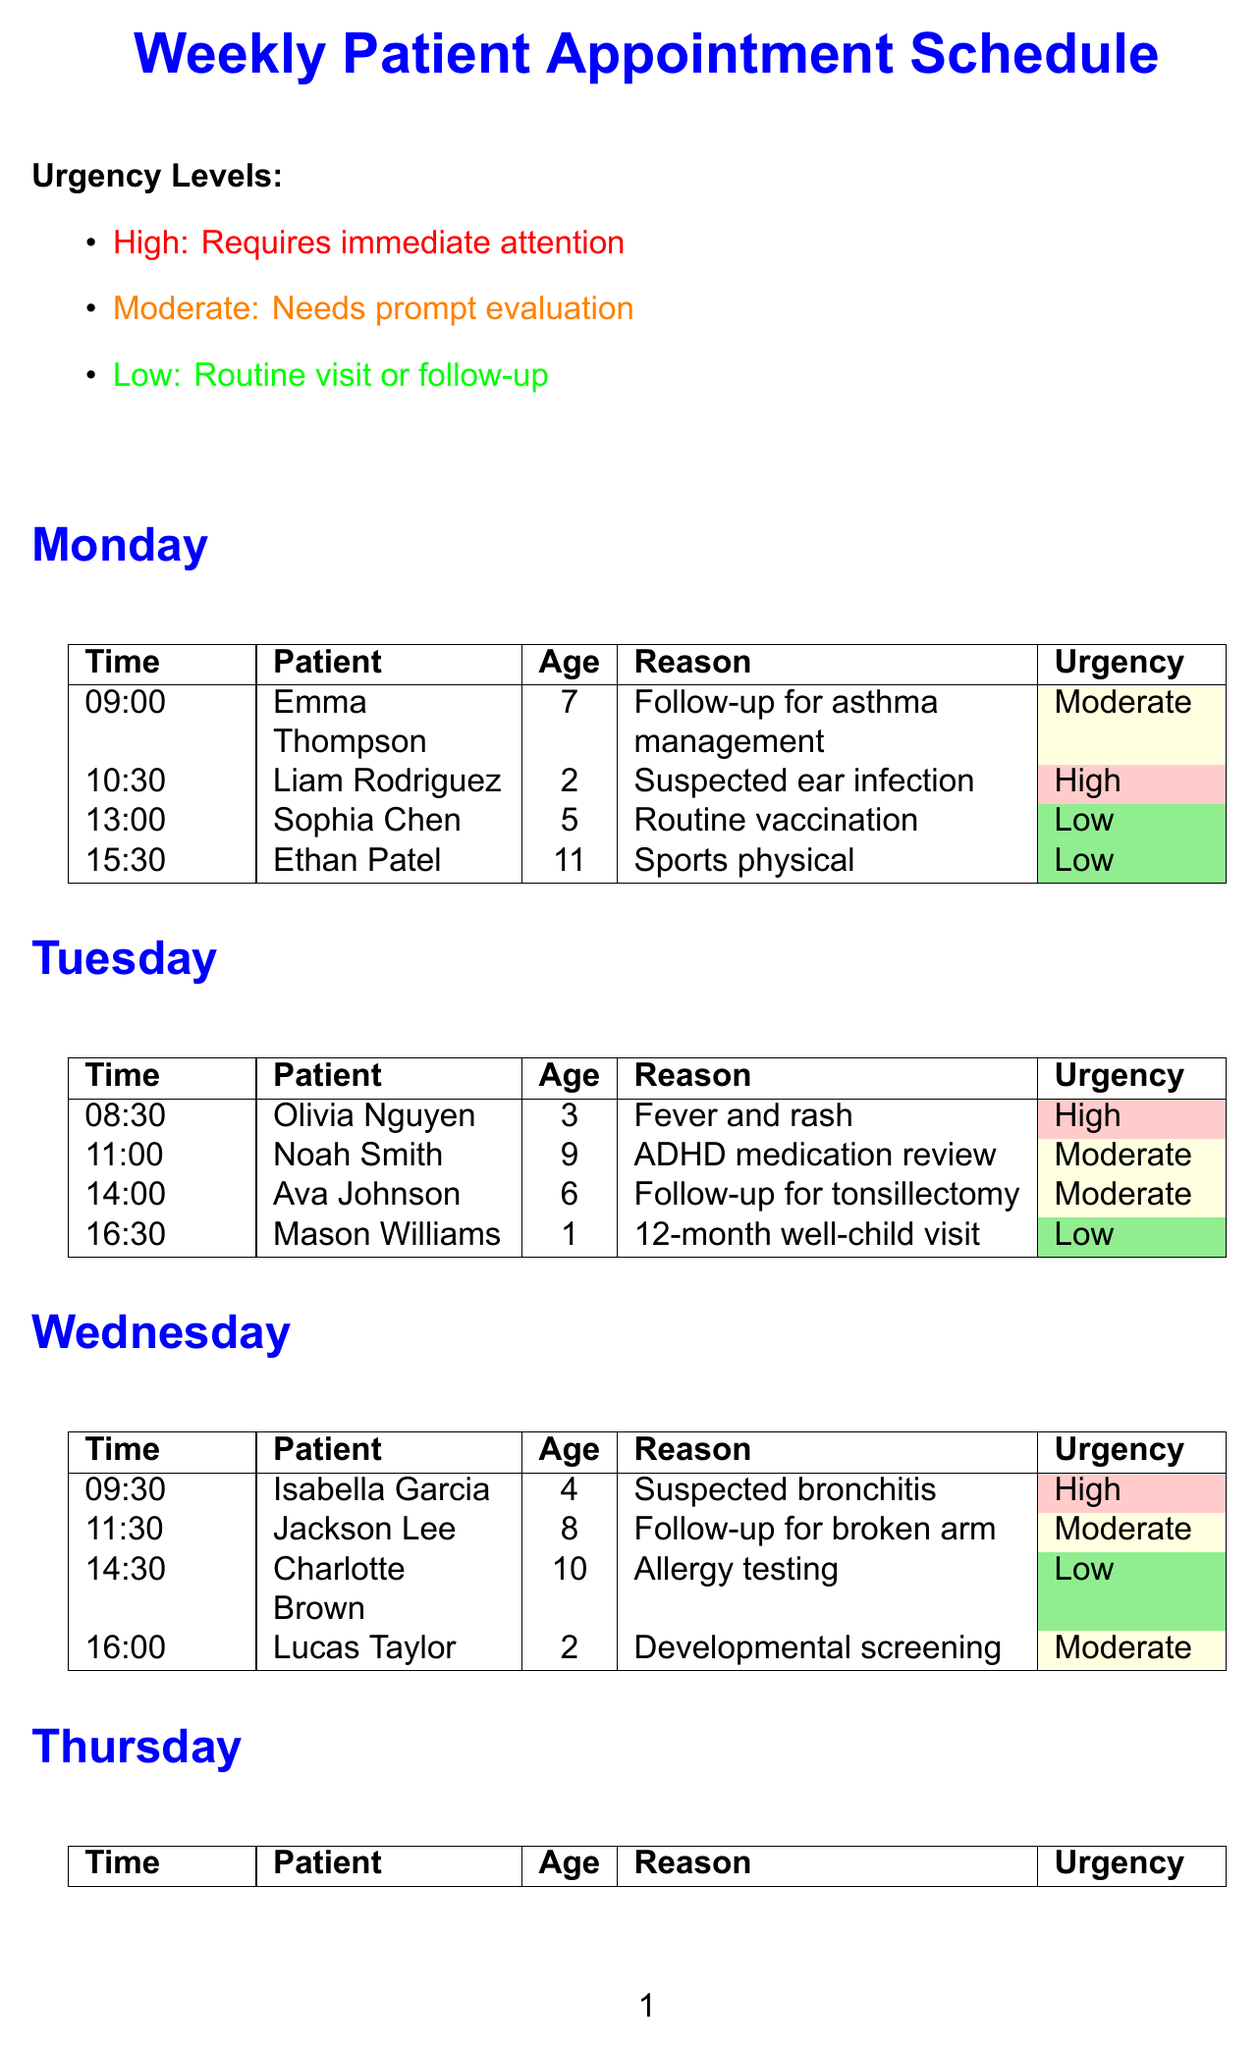What is the reason for Liam Rodriguez's appointment? The reason is specified in the document as "Suspected ear infection."
Answer: Suspected ear infection How many appointments are there on Thursday? The document lists four appointments for Thursday.
Answer: 4 What time is Amelia Thomas's appointment? The document states that Amelia Thomas's appointment is scheduled for 09:00.
Answer: 09:00 Which patient is scheduled for a follow-up for pneumonia? The appointment for a follow-up for pneumonia is noted for Harper Anderson on Thursday.
Answer: Harper Anderson How many patients have a high urgency level? The document indicates that there are four patients with a high urgency level (Liam Rodriguez, Olivia Nguyen, Isabella Garcia, Mia Martinez, and Amelia Thomas).
Answer: 5 What is the color code for moderate urgency? The document refers to the moderate urgency level with the color code yellow.
Answer: Yellow Which day has the most high urgency appointments? Wednesday and Friday each have two high urgency appointments, while other days have one.
Answer: Wednesday and Friday What note is related to Ava Johnson? The document states to "Discuss potential tonsillectomy with Ava Johnson's parents."
Answer: Discuss potential tonsillectomy with Ava Johnson's parents What is the age of Ethan Patel? The document lists Ethan Patel's age as 11.
Answer: 11 